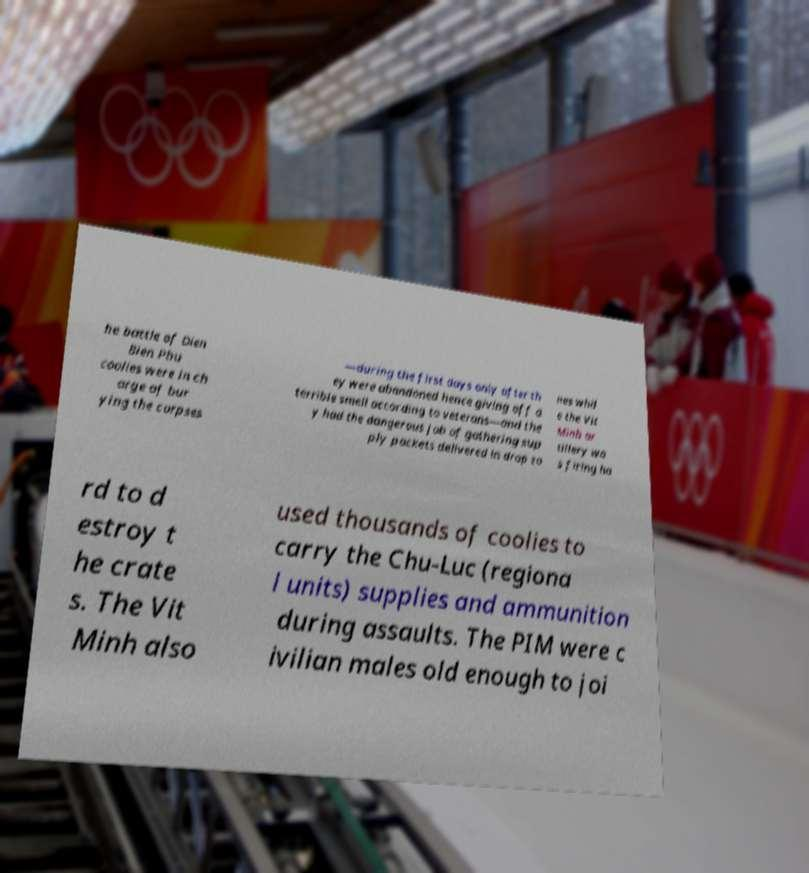Can you accurately transcribe the text from the provided image for me? he battle of Dien Bien Phu coolies were in ch arge of bur ying the corpses —during the first days only after th ey were abandoned hence giving off a terrible smell according to veterans—and the y had the dangerous job of gathering sup ply packets delivered in drop zo nes whil e the Vit Minh ar tillery wa s firing ha rd to d estroy t he crate s. The Vit Minh also used thousands of coolies to carry the Chu-Luc (regiona l units) supplies and ammunition during assaults. The PIM were c ivilian males old enough to joi 